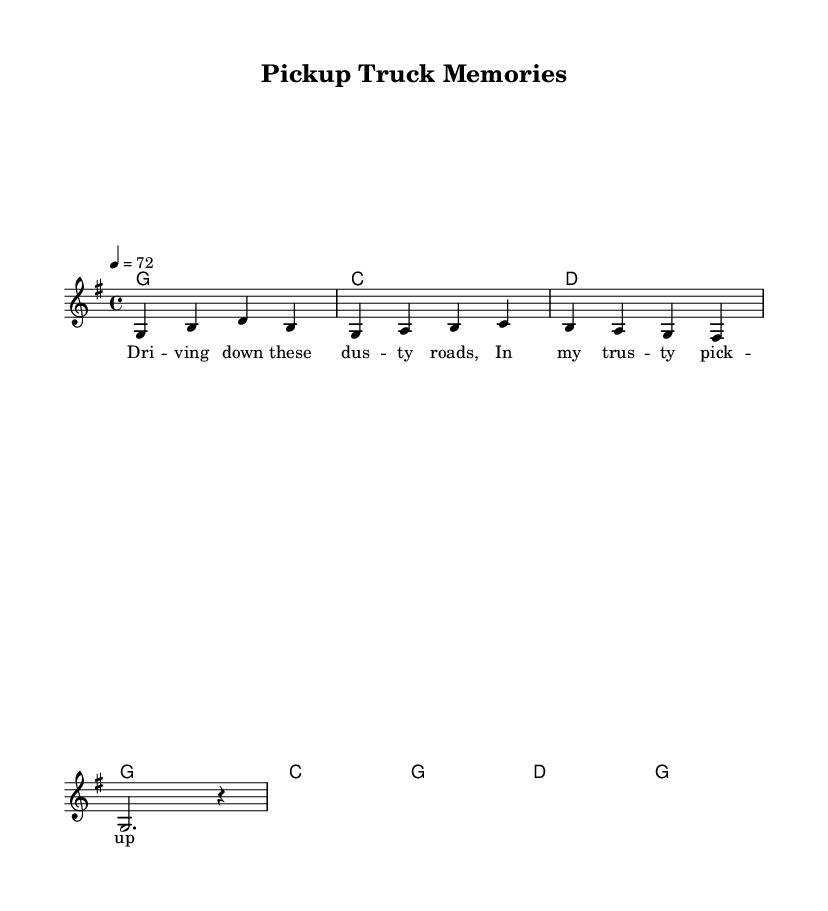What is the key signature of this music? The key signature is G major, which has one sharp (F#). This is determined by the global settings at the beginning of the score that specify the key.
Answer: G major What is the time signature of this piece? The time signature is 4/4, which indicates that there are four beats in each measure and the quarter note receives one beat. This is also stated in the global settings right at the start.
Answer: 4/4 What is the tempo marking? The tempo marking is a quarter note equals 72 beats per minute, which indicates how fast the piece should be played. This is found in the global settings as well.
Answer: 72 How many chords are used in the verse? The verse includes four chords: G, C, D, and G. Each chord corresponds to the measures in the chord section of the score. Counting the chord symbols, we can verify that the verse features one of each chord.
Answer: Four How many measures are present in the chorus? The chorus consists of four measures, as indicated by the four chord symbols listed for the chorus section. Each chord corresponds to a measure, showing that the chorus has four measures total.
Answer: Four Which lyrics correspond to the melody? The lyrics "Driving down these dusty roads, In my trusty pickup truck," correspond to the melody. They are placed directly beneath the musical notes in the lyrics section of the score, showing how they align with the melody.
Answer: Driving down these dusty roads, In my trusty pickup truck What theme is evident in the song? The theme is focused on small-town life and personal experiences associated with a pickup truck. This can be inferred from both the lyrics and the song's title, which relates directly to these subjects.
Answer: Small-town life and pickup trucks 